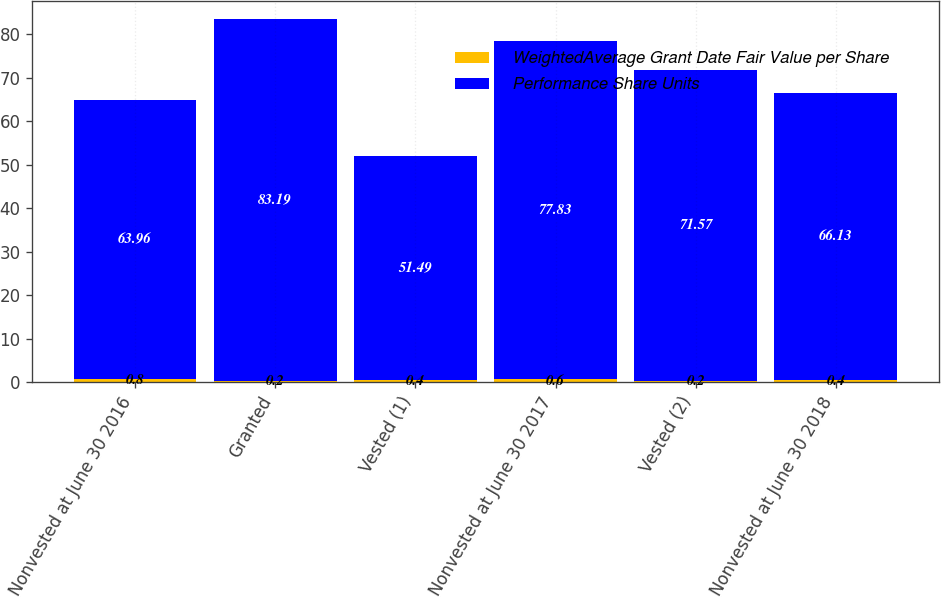<chart> <loc_0><loc_0><loc_500><loc_500><stacked_bar_chart><ecel><fcel>Nonvested at June 30 2016<fcel>Granted<fcel>Vested (1)<fcel>Nonvested at June 30 2017<fcel>Vested (2)<fcel>Nonvested at June 30 2018<nl><fcel>WeightedAverage Grant Date Fair Value per Share<fcel>0.8<fcel>0.2<fcel>0.4<fcel>0.6<fcel>0.2<fcel>0.4<nl><fcel>Performance Share Units<fcel>63.96<fcel>83.19<fcel>51.49<fcel>77.83<fcel>71.57<fcel>66.13<nl></chart> 